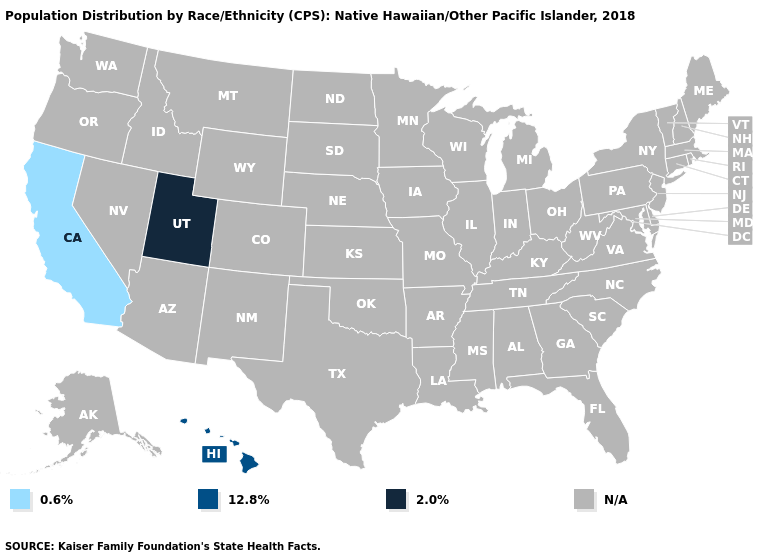What is the value of South Dakota?
Give a very brief answer. N/A. What is the value of Kansas?
Give a very brief answer. N/A. What is the value of Wisconsin?
Give a very brief answer. N/A. Which states have the lowest value in the West?
Keep it brief. California. Is the legend a continuous bar?
Quick response, please. No. Is the legend a continuous bar?
Short answer required. No. Name the states that have a value in the range N/A?
Concise answer only. Alabama, Alaska, Arizona, Arkansas, Colorado, Connecticut, Delaware, Florida, Georgia, Idaho, Illinois, Indiana, Iowa, Kansas, Kentucky, Louisiana, Maine, Maryland, Massachusetts, Michigan, Minnesota, Mississippi, Missouri, Montana, Nebraska, Nevada, New Hampshire, New Jersey, New Mexico, New York, North Carolina, North Dakota, Ohio, Oklahoma, Oregon, Pennsylvania, Rhode Island, South Carolina, South Dakota, Tennessee, Texas, Vermont, Virginia, Washington, West Virginia, Wisconsin, Wyoming. Does Utah have the lowest value in the West?
Write a very short answer. No. Does the map have missing data?
Give a very brief answer. Yes. Does California have the highest value in the USA?
Quick response, please. No. Does the map have missing data?
Concise answer only. Yes. What is the value of Iowa?
Write a very short answer. N/A. What is the lowest value in the USA?
Give a very brief answer. 0.6%. What is the value of Virginia?
Keep it brief. N/A. 